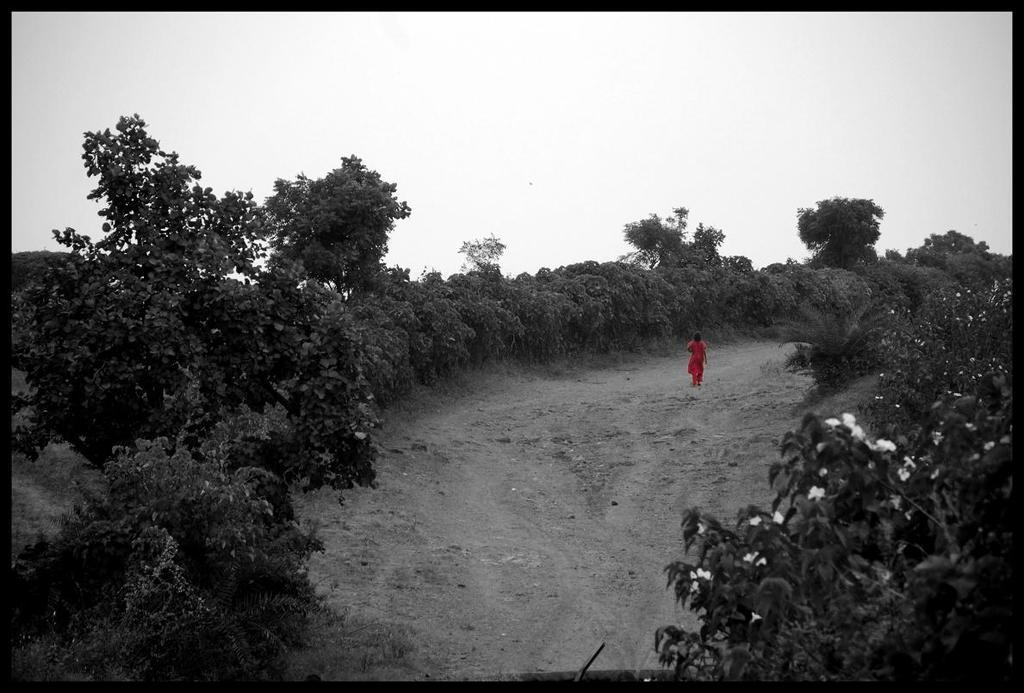What is the main subject of the image? There is a person walking in the middle of the image. What can be seen on either side of the person? There are trees on either side of the image. What is visible at the top of the image? The sky is visible at the top of the image. What type of vegetation is on the right side of the image? There are flowers on the right side of the image. What type of cap can be seen on the person's head in the image? There is no cap visible on the person's head in the image. How is the division between the trees and the sky represented in the image? The image does not depict a division between the trees and the sky; it shows both elements together. Where is the faucet located in the image? There is no faucet present in the image. 